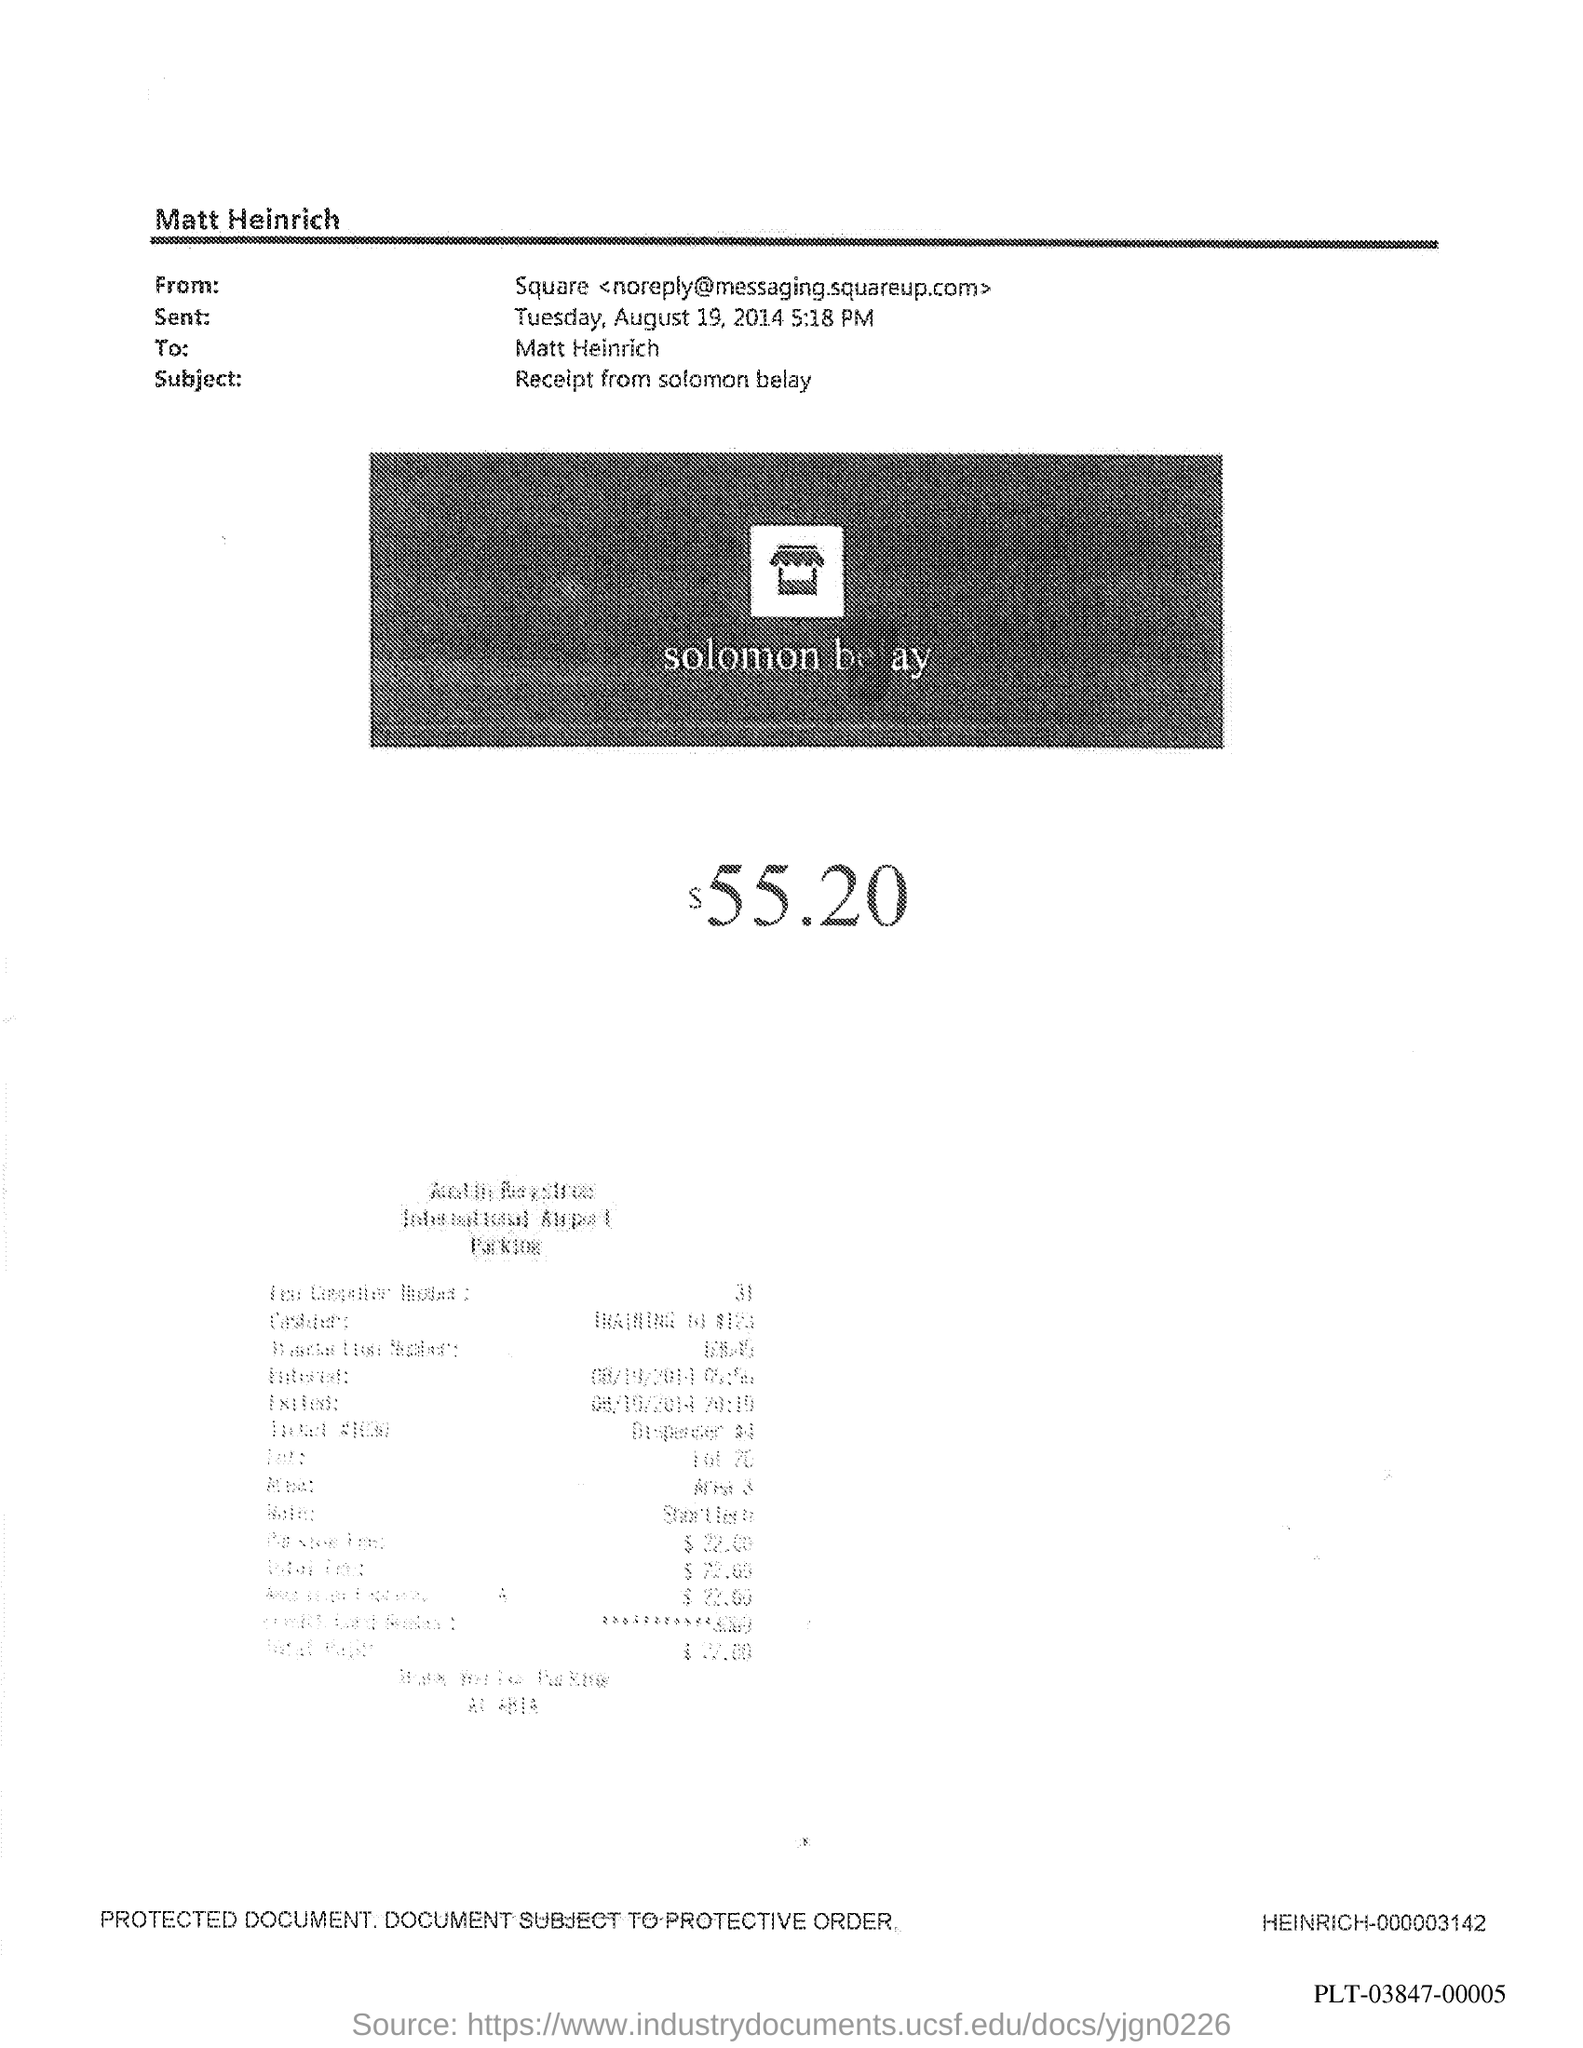List a handful of essential elements in this visual. The subject in the document is a receipt from Solomon Belay. 